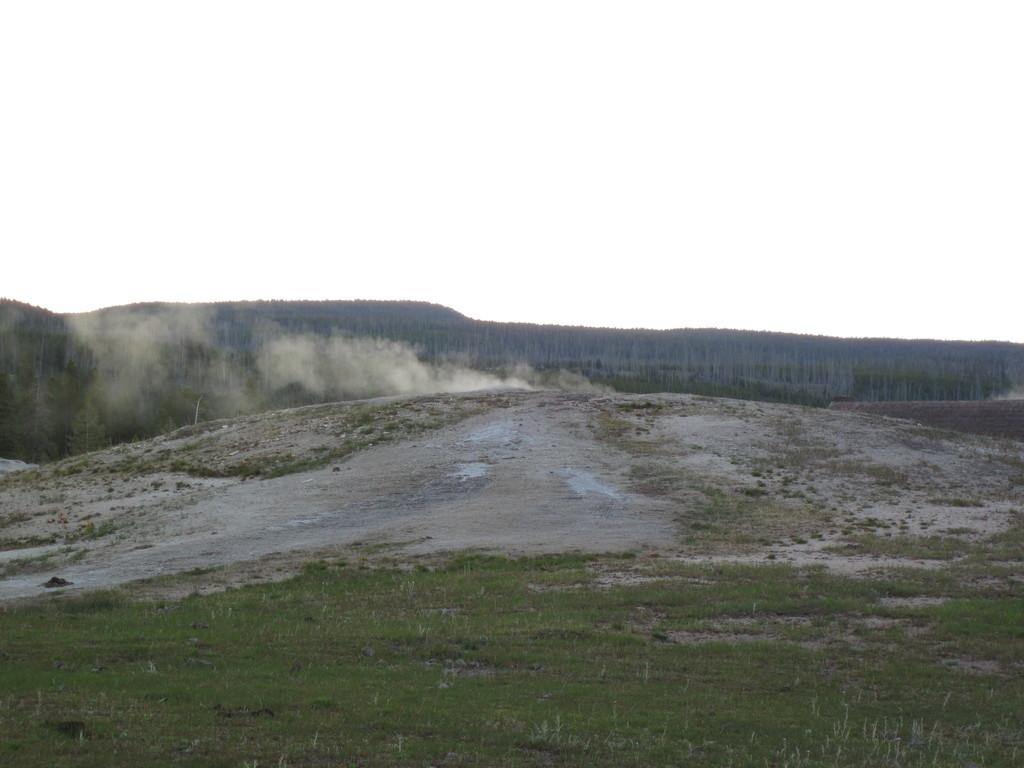What type of landscape is shown in the image? There is a hill view in the image. What can be seen in the middle of the image? Smoke is visible in the middle of the image. What is visible at the top of the image? The sky is visible at the top of the image. What color is the lead that the father is holding in the image? There is no lead or father present in the image; it only features a hill view with smoke and the sky. 